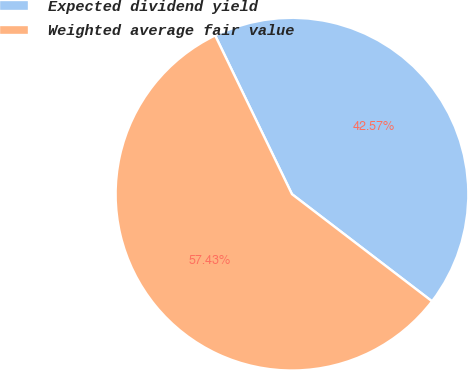Convert chart to OTSL. <chart><loc_0><loc_0><loc_500><loc_500><pie_chart><fcel>Expected dividend yield<fcel>Weighted average fair value<nl><fcel>42.57%<fcel>57.43%<nl></chart> 